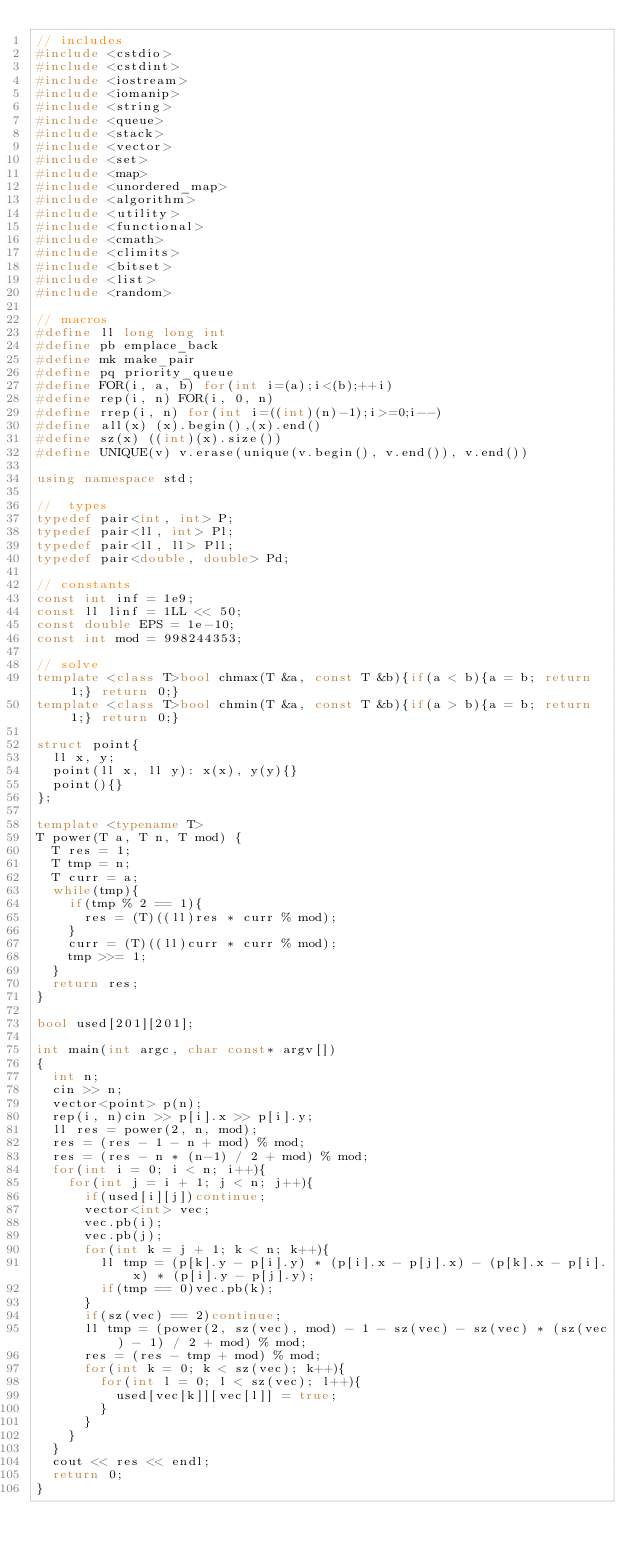<code> <loc_0><loc_0><loc_500><loc_500><_C++_>// includes
#include <cstdio>
#include <cstdint>
#include <iostream>
#include <iomanip>
#include <string>
#include <queue>
#include <stack>
#include <vector>
#include <set>
#include <map>
#include <unordered_map>
#include <algorithm>
#include <utility>
#include <functional>
#include <cmath>
#include <climits>
#include <bitset>
#include <list>
#include <random>

// macros
#define ll long long int
#define pb emplace_back
#define mk make_pair
#define pq priority_queue
#define FOR(i, a, b) for(int i=(a);i<(b);++i)
#define rep(i, n) FOR(i, 0, n)
#define rrep(i, n) for(int i=((int)(n)-1);i>=0;i--)
#define all(x) (x).begin(),(x).end()
#define sz(x) ((int)(x).size())
#define UNIQUE(v) v.erase(unique(v.begin(), v.end()), v.end())

using namespace std;

//  types
typedef pair<int, int> P;
typedef pair<ll, int> Pl;
typedef pair<ll, ll> Pll;
typedef pair<double, double> Pd;
 
// constants
const int inf = 1e9;
const ll linf = 1LL << 50;
const double EPS = 1e-10;
const int mod = 998244353;

// solve
template <class T>bool chmax(T &a, const T &b){if(a < b){a = b; return 1;} return 0;}
template <class T>bool chmin(T &a, const T &b){if(a > b){a = b; return 1;} return 0;}

struct point{
  ll x, y;
  point(ll x, ll y): x(x), y(y){}
  point(){}
};

template <typename T>
T power(T a, T n, T mod) {
  T res = 1;
  T tmp = n;
  T curr = a;
  while(tmp){
    if(tmp % 2 == 1){
      res = (T)((ll)res * curr % mod);
    }
    curr = (T)((ll)curr * curr % mod);
    tmp >>= 1;
  }
  return res;
}

bool used[201][201];

int main(int argc, char const* argv[])
{
  int n;
  cin >> n;
  vector<point> p(n);
  rep(i, n)cin >> p[i].x >> p[i].y;
  ll res = power(2, n, mod);
  res = (res - 1 - n + mod) % mod;
  res = (res - n * (n-1) / 2 + mod) % mod;
  for(int i = 0; i < n; i++){
    for(int j = i + 1; j < n; j++){
      if(used[i][j])continue;
      vector<int> vec;
      vec.pb(i);
      vec.pb(j);
      for(int k = j + 1; k < n; k++){
        ll tmp = (p[k].y - p[i].y) * (p[i].x - p[j].x) - (p[k].x - p[i].x) * (p[i].y - p[j].y);
        if(tmp == 0)vec.pb(k);
      }
      if(sz(vec) == 2)continue;
      ll tmp = (power(2, sz(vec), mod) - 1 - sz(vec) - sz(vec) * (sz(vec) - 1) / 2 + mod) % mod;
      res = (res - tmp + mod) % mod;
      for(int k = 0; k < sz(vec); k++){
        for(int l = 0; l < sz(vec); l++){
          used[vec[k]][vec[l]] = true;
        }
      }
    }
  }
  cout << res << endl;
	return 0;
}
</code> 